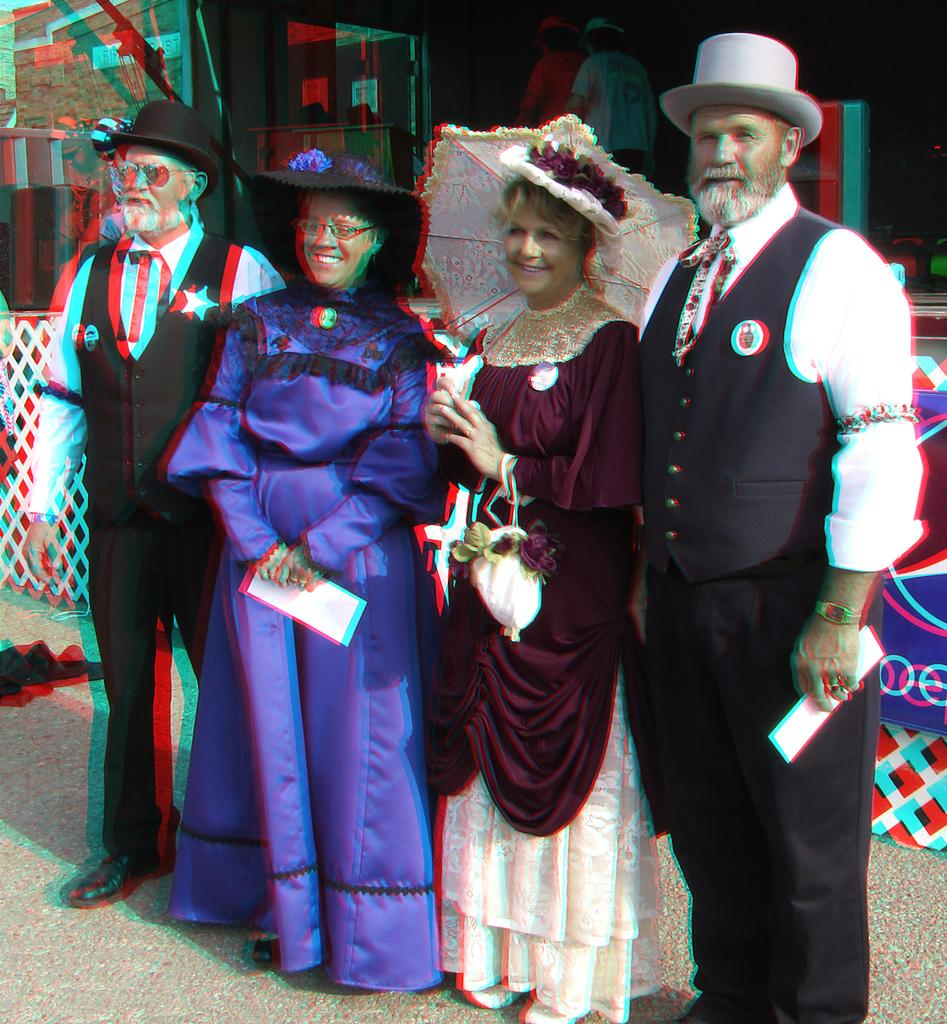How many people are present in the image? There are four people standing in the image. What is the surface on which the people are standing? The people are standing on the ground. What can be seen in the background of the image? There is a railing in the background of the image. How would you describe the appearance of the railing? The railing appears to be blurred. Can you see any frogs jumping around near the railing in the image? There are no frogs visible in the image; it only features four people standing on the ground and a blurred railing in the background. 